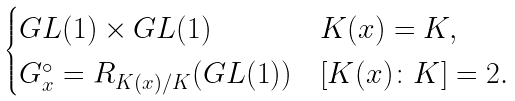Convert formula to latex. <formula><loc_0><loc_0><loc_500><loc_500>\begin{cases} G L ( 1 ) \times G L ( 1 ) & K ( x ) = K , \\ G _ { x } ^ { \circ } = R _ { K ( x ) / K } ( G L ( 1 ) ) & [ K ( x ) \colon K ] = 2 . \end{cases}</formula> 